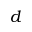Convert formula to latex. <formula><loc_0><loc_0><loc_500><loc_500>d</formula> 